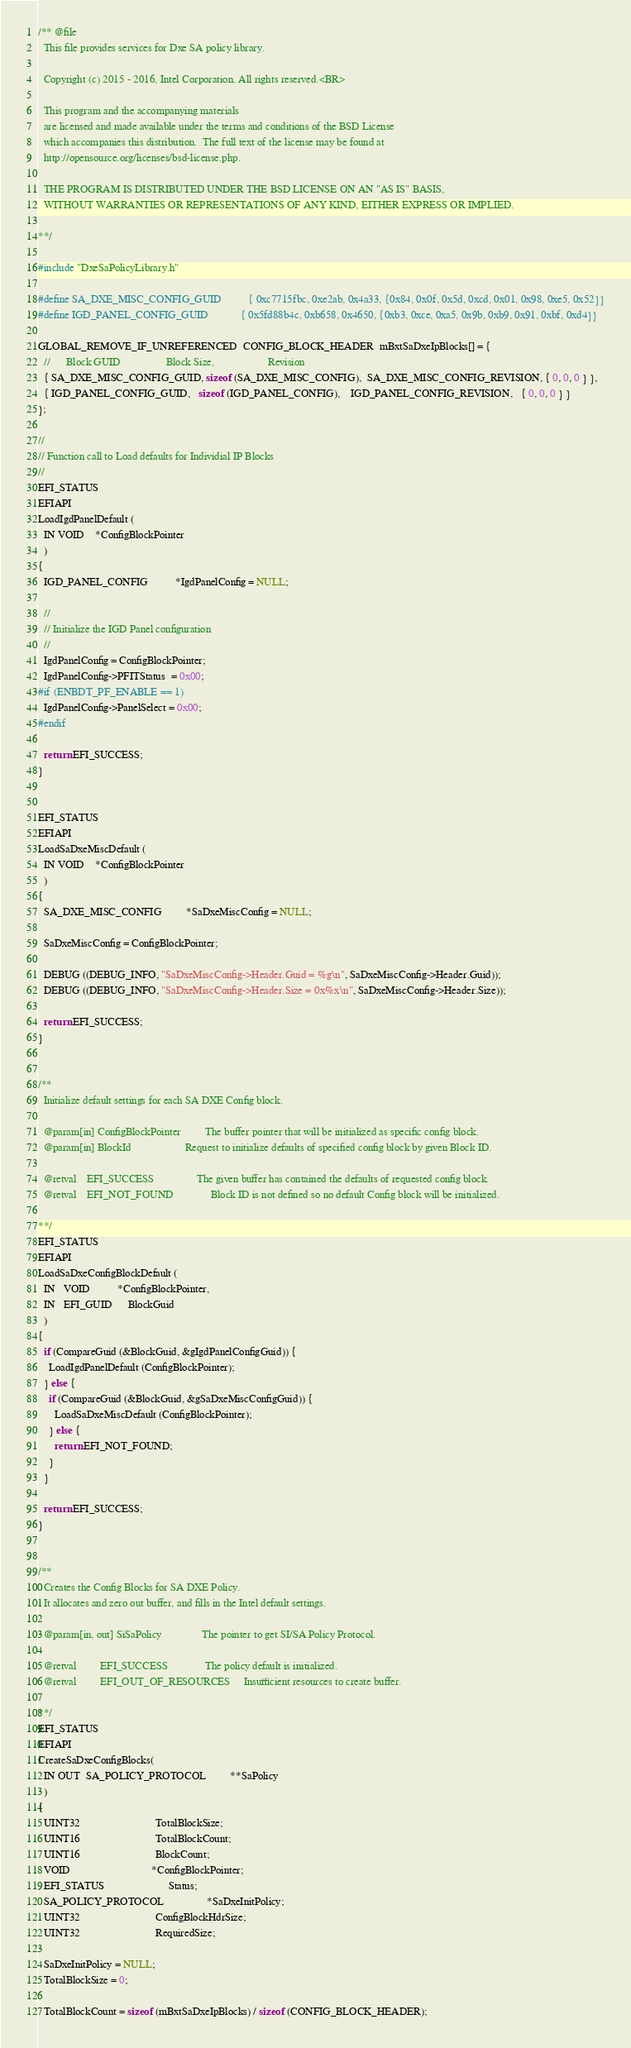<code> <loc_0><loc_0><loc_500><loc_500><_C_>/** @file
  This file provides services for Dxe SA policy library.

  Copyright (c) 2015 - 2016, Intel Corporation. All rights reserved.<BR>

  This program and the accompanying materials
  are licensed and made available under the terms and conditions of the BSD License
  which accompanies this distribution.  The full text of the license may be found at
  http://opensource.org/licenses/bsd-license.php.

  THE PROGRAM IS DISTRIBUTED UNDER THE BSD LICENSE ON AN "AS IS" BASIS,
  WITHOUT WARRANTIES OR REPRESENTATIONS OF ANY KIND, EITHER EXPRESS OR IMPLIED.

**/

#include "DxeSaPolicyLibrary.h"

#define SA_DXE_MISC_CONFIG_GUID          { 0xc7715fbc, 0xe2ab, 0x4a33, {0x84, 0x0f, 0x5d, 0xcd, 0x01, 0x98, 0xe5, 0x52}}
#define IGD_PANEL_CONFIG_GUID            { 0x5fd88b4c, 0xb658, 0x4650, {0xb3, 0xce, 0xa5, 0x9b, 0xb9, 0x91, 0xbf, 0xd4}}

GLOBAL_REMOVE_IF_UNREFERENCED  CONFIG_BLOCK_HEADER  mBxtSaDxeIpBlocks[] = {
  //      Block GUID                 Block Size,                    Revision
  { SA_DXE_MISC_CONFIG_GUID, sizeof (SA_DXE_MISC_CONFIG),  SA_DXE_MISC_CONFIG_REVISION, { 0, 0, 0 } },
  { IGD_PANEL_CONFIG_GUID,   sizeof (IGD_PANEL_CONFIG),    IGD_PANEL_CONFIG_REVISION,   { 0, 0, 0 } }
};

//
// Function call to Load defaults for Individial IP Blocks
//
EFI_STATUS
EFIAPI
LoadIgdPanelDefault (
  IN VOID    *ConfigBlockPointer
  )
{
  IGD_PANEL_CONFIG          *IgdPanelConfig = NULL;

  //
  // Initialize the IGD Panel configuration
  //
  IgdPanelConfig = ConfigBlockPointer;
  IgdPanelConfig->PFITStatus  = 0x00;
#if (ENBDT_PF_ENABLE == 1)
  IgdPanelConfig->PanelSelect = 0x00;
#endif

  return EFI_SUCCESS;
}


EFI_STATUS
EFIAPI
LoadSaDxeMiscDefault (
  IN VOID    *ConfigBlockPointer
  )
{
  SA_DXE_MISC_CONFIG         *SaDxeMiscConfig = NULL;

  SaDxeMiscConfig = ConfigBlockPointer;

  DEBUG ((DEBUG_INFO, "SaDxeMiscConfig->Header.Guid = %g\n", SaDxeMiscConfig->Header.Guid));
  DEBUG ((DEBUG_INFO, "SaDxeMiscConfig->Header.Size = 0x%x\n", SaDxeMiscConfig->Header.Size));

  return EFI_SUCCESS;
}


/**
  Initialize default settings for each SA DXE Config block.

  @param[in] ConfigBlockPointer         The buffer pointer that will be initialized as specific config block.
  @param[in] BlockId                    Request to initialize defaults of specified config block by given Block ID.

  @retval    EFI_SUCCESS                The given buffer has contained the defaults of requested config block.
  @retval    EFI_NOT_FOUND              Block ID is not defined so no default Config block will be initialized.

**/
EFI_STATUS
EFIAPI
LoadSaDxeConfigBlockDefault (
  IN   VOID          *ConfigBlockPointer,
  IN   EFI_GUID      BlockGuid
  )
{
  if (CompareGuid (&BlockGuid, &gIgdPanelConfigGuid)) {
    LoadIgdPanelDefault (ConfigBlockPointer);
  } else {
    if (CompareGuid (&BlockGuid, &gSaDxeMiscConfigGuid)) {
      LoadSaDxeMiscDefault (ConfigBlockPointer);
    } else {
      return EFI_NOT_FOUND;
    }
  }

  return EFI_SUCCESS;
}


/**
  Creates the Config Blocks for SA DXE Policy.
  It allocates and zero out buffer, and fills in the Intel default settings.

  @param[in, out] SiSaPolicy               The pointer to get SI/SA Policy Protocol.

  @retval         EFI_SUCCESS              The policy default is initialized.
  @retval         EFI_OUT_OF_RESOURCES     Insufficient resources to create buffer.

**/
EFI_STATUS
EFIAPI
CreateSaDxeConfigBlocks(
  IN OUT  SA_POLICY_PROTOCOL         **SaPolicy
  )
{
  UINT32                            TotalBlockSize;
  UINT16                            TotalBlockCount;
  UINT16                            BlockCount;
  VOID                              *ConfigBlockPointer;
  EFI_STATUS                        Status;
  SA_POLICY_PROTOCOL                *SaDxeInitPolicy;
  UINT32                            ConfigBlockHdrSize;
  UINT32                            RequiredSize;

  SaDxeInitPolicy = NULL;
  TotalBlockSize = 0;

  TotalBlockCount = sizeof (mBxtSaDxeIpBlocks) / sizeof (CONFIG_BLOCK_HEADER);</code> 